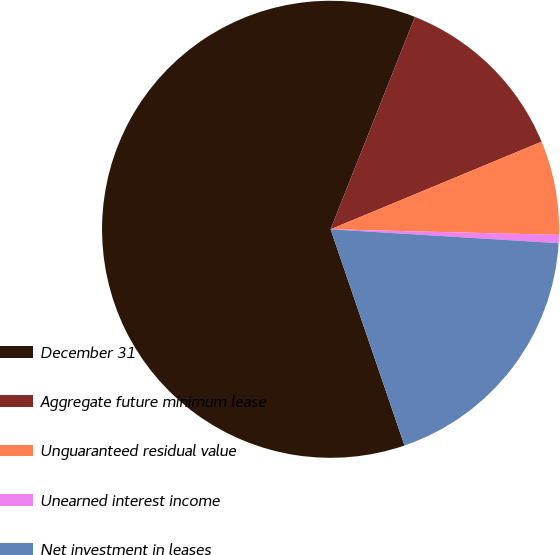<chart> <loc_0><loc_0><loc_500><loc_500><pie_chart><fcel>December 31<fcel>Aggregate future minimum lease<fcel>Unguaranteed residual value<fcel>Unearned interest income<fcel>Net investment in leases<nl><fcel>61.27%<fcel>12.72%<fcel>6.65%<fcel>0.58%<fcel>18.79%<nl></chart> 